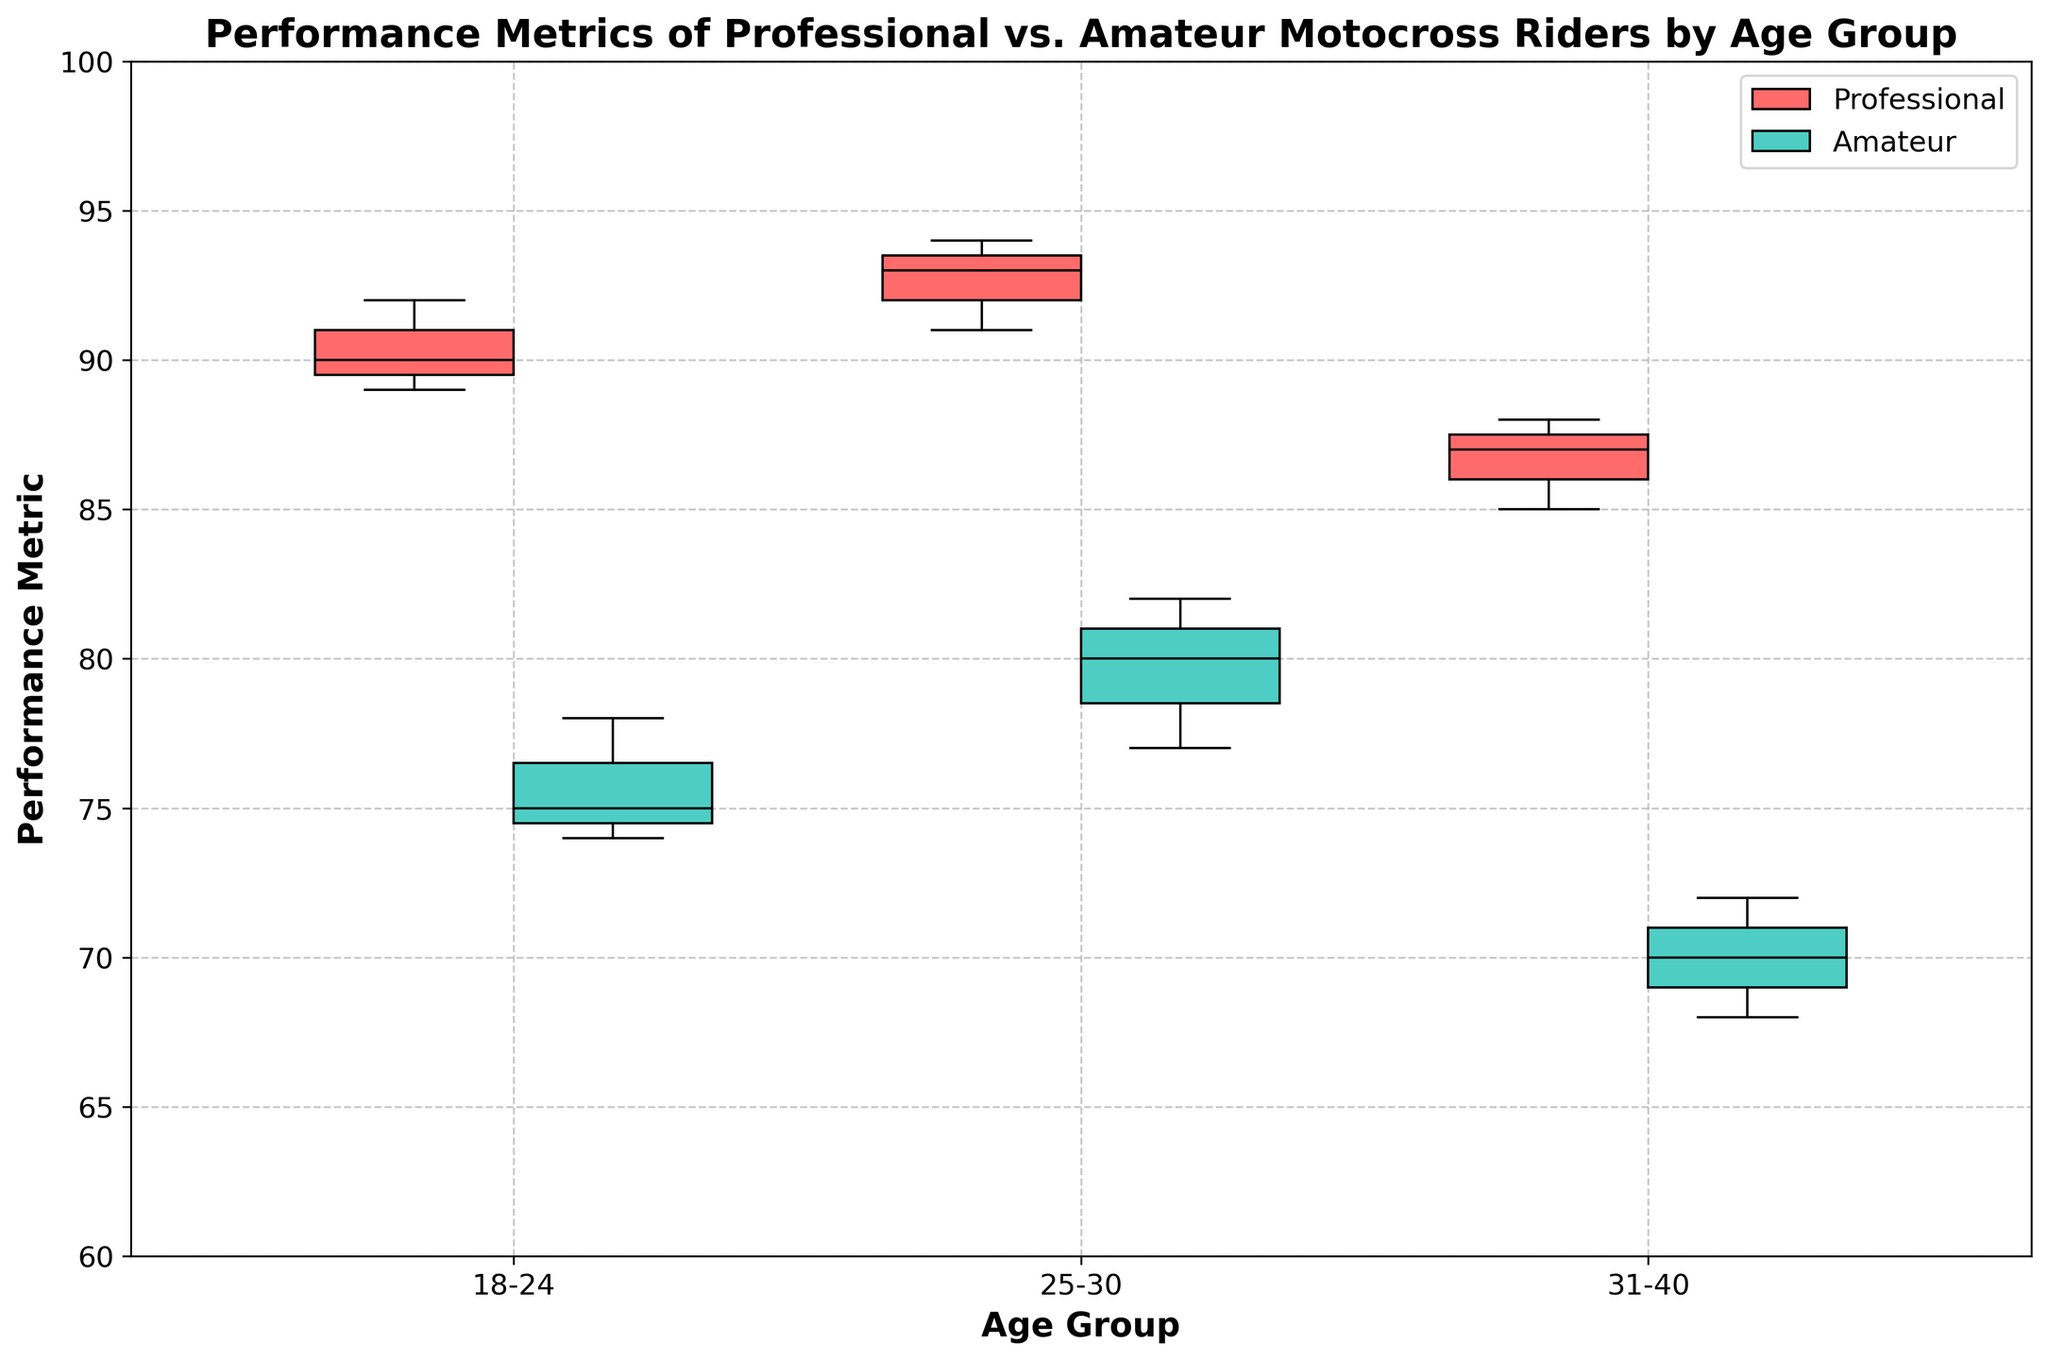What is the title of the figure? The title of the figure is displayed at the top center of the plot. It is "Performance Metrics of Professional vs. Amateur Motocross Riders by Age Group."
Answer: Performance Metrics of Professional vs. Amateur Motocross Riders by Age Group What colors represent Professional and Amateur riders in the box plot? The box plot uses distinct colors for different rider types. Professional riders are represented by red boxes, while Amateur riders are represented by teal boxes.
Answer: Red for Professional, teal for Amateur What is the highest median performance metric for Professional riders, and in which age group does it occur? By looking at the line inside the red boxes (indicating medians), the highest median value for Professional riders is observed in the 25-30 age group.
Answer: 94 in the 25-30 age group Which age group shows the largest interquartile range (IQR) for Amateur riders? To determine the largest IQR, we need to assess the height of the teal boxes. The 25-30 age group has the tallest box for Amateur riders, indicating the largest IQR.
Answer: 25-30 age group How does the median performance metric for Amateur riders in the 18-24 age group compare to the median performance metric for Professional riders in the same age group? The line inside the teal box represents the Amateur riders' median, which is around 76. In comparison, the median for Professional riders (red box) is around 90.
Answer: Amateur: 76, Professional: 90 In which age group is the difference between the median performance metrics of Professional and Amateur riders the smallest? Compare the distance between the medians (lines within the boxes) of Professional and Amateur riders across all age groups. The smallest difference is in the 31-40 age group.
Answer: 31-40 age group What can be inferred about the performance consistency of Professional vs. Amateur riders in the 31-40 age group? Assessing the spread of the boxes and whiskers, Professional riders show a smaller spread, indicating more consistent performance metrics, while Amateur riders display a larger spread, indicating more variability.
Answer: Professional riders show more consistency What is the approximate median performance metric for Amateur riders in the 25-30 age group? The median of Amateur riders in the 25-30 age group is the line inside the teal box. It is approximately around 79.
Answer: Approximately 79 Which group has the lowest overall performance metric, and in which age group? The lowest value is represented by the lowest point (bottom whisker) of any box plot. The lowest overall performance metric is for Amateur riders in the 31-40 age group, around 68.
Answer: Amateur in the 31-40 age group, around 68 